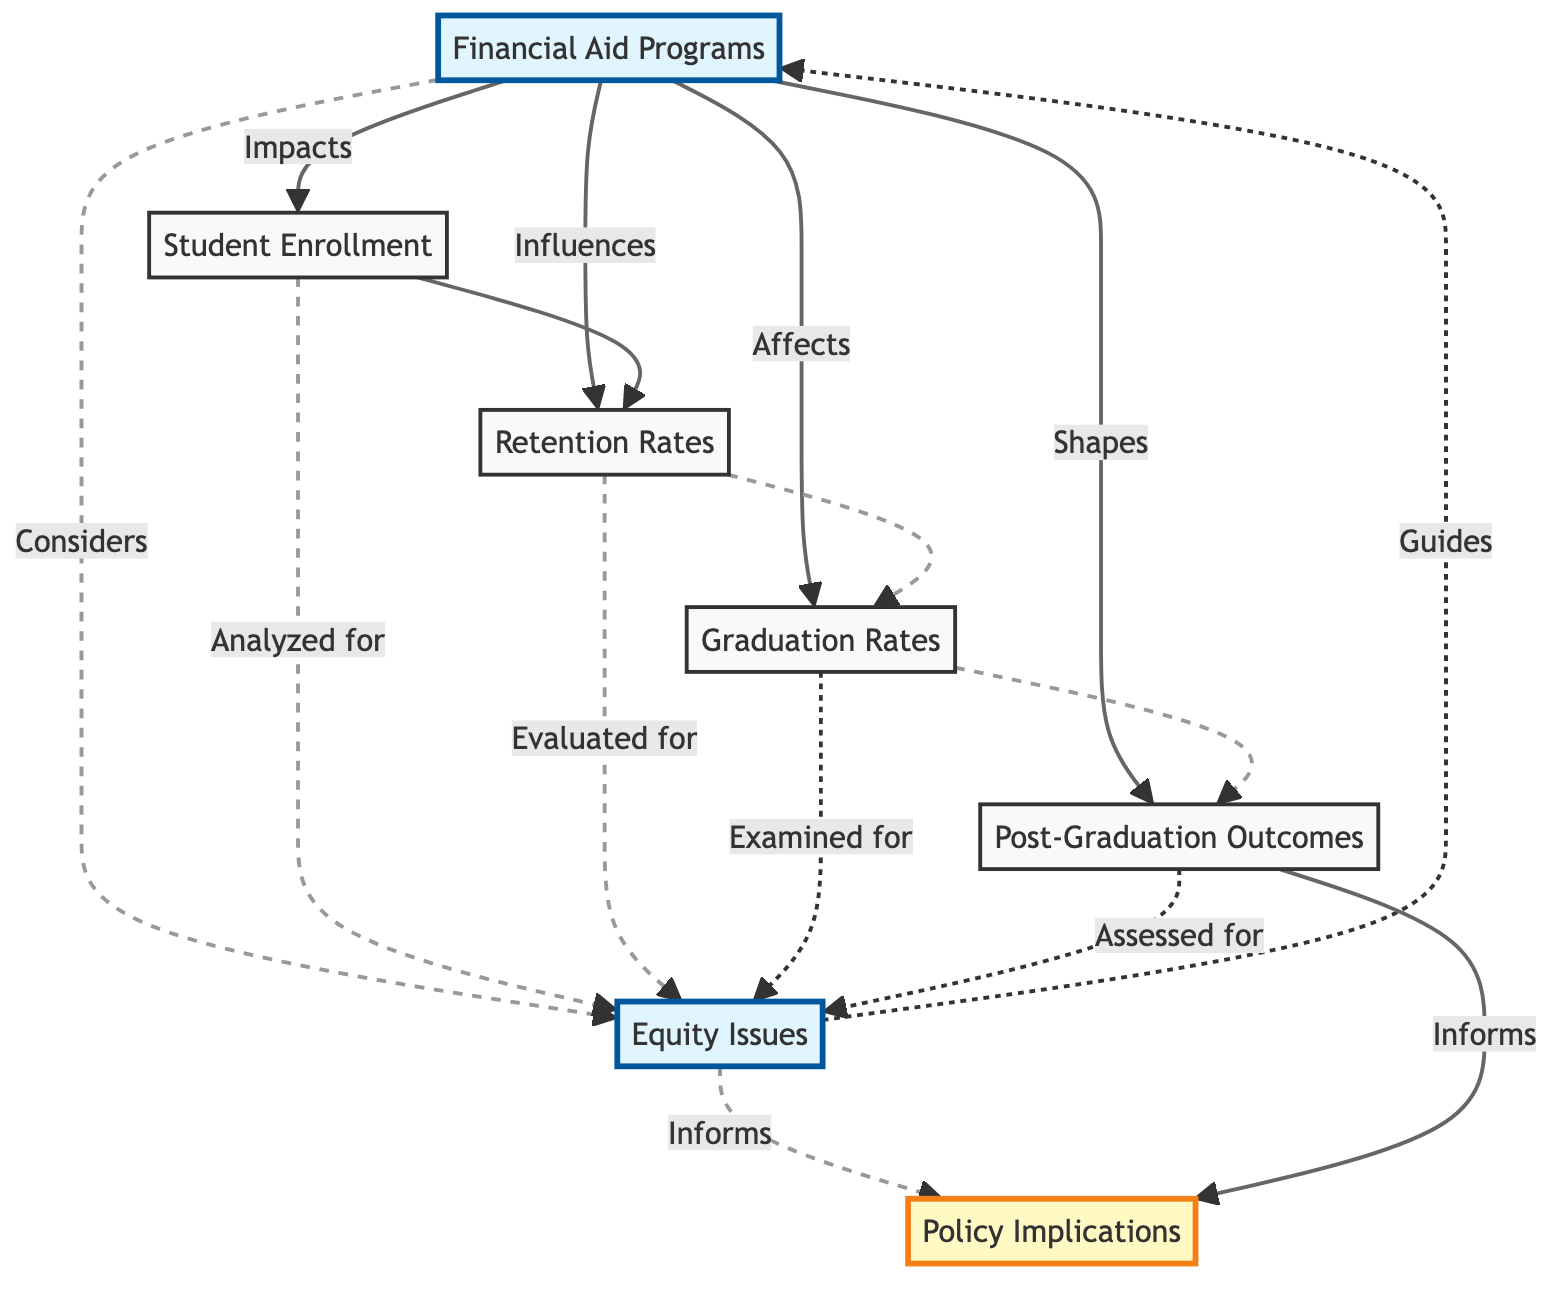What are the types of financial aid programs? According to the diagram, financial aid programs include Pell Grants, federal student loans, and scholarships, which are defined in the node "Financial Aid Programs."
Answer: Pell Grants, federal student loans, and scholarships Which factors does financial aid impact directly? The diagram shows that financial aid directly impacts Student Enrollment, Retention Rates, Graduation Rates, and Post-Graduation Outcomes, as indicated by the arrows pointing from "Financial Aid Programs" to these nodes.
Answer: Student Enrollment, Retention Rates, Graduation Rates, Post-Graduation Outcomes How many nodes are connected to "Equity Issues"? From the diagram, we note that there are five nodes that connect to "Equity Issues," including "Financial Aid Programs," "Student Enrollment," "Retention Rates," "Graduation Rates," and "Post-Graduation Outcomes." The total is counted as part of the connections.
Answer: 5 What role does "Equity Issues" play in determining policy implications? The diagram reveals that "Equity Issues" informs "Policy Implications," indicated by the directed arrow from "Equity Issues" to "Policy Implications." This establishes that an analysis of equity issues directly guides policy recommendations.
Answer: Guides Which node leads to "Post-Graduation Outcomes"? The flow from the diagram shows that "Graduation Rates" directly influences "Post-Graduation Outcomes," as depicted by the arrow pointing from "Graduation Rates" to "Post-Graduation Outcomes."
Answer: Graduation Rates What type of relationship exists between "Student Enrollment" and "Retention Rates"? The diagram indicates a direct relationship exists, with an arrow stemming from "Student Enrollment" leading to "Retention Rates," signifying that changes in enrollment can affect retention outcomes.
Answer: Impacts Explain how "Financial Aid Programs" shape "Equity Issues." The diagram specifies a dotted line from "Financial Aid Programs" to "Equity Issues," labeled as "Considers," which implies that the types of financial aid programs take into account the disparities faced by students related to equity issues. Thus, there's an indirect consideration of how financial aid impacts equity.
Answer: Considers What is the relationship between "Post-Graduation Outcomes" and "Policy Implications"? The flowchart illustrates a directed connection from "Post-Graduation Outcomes" to "Policy Implications," marked with the label "Informs," suggesting that information gathered from post-graduation outcomes can be used to shape or recommend policy adjustments.
Answer: Informs 